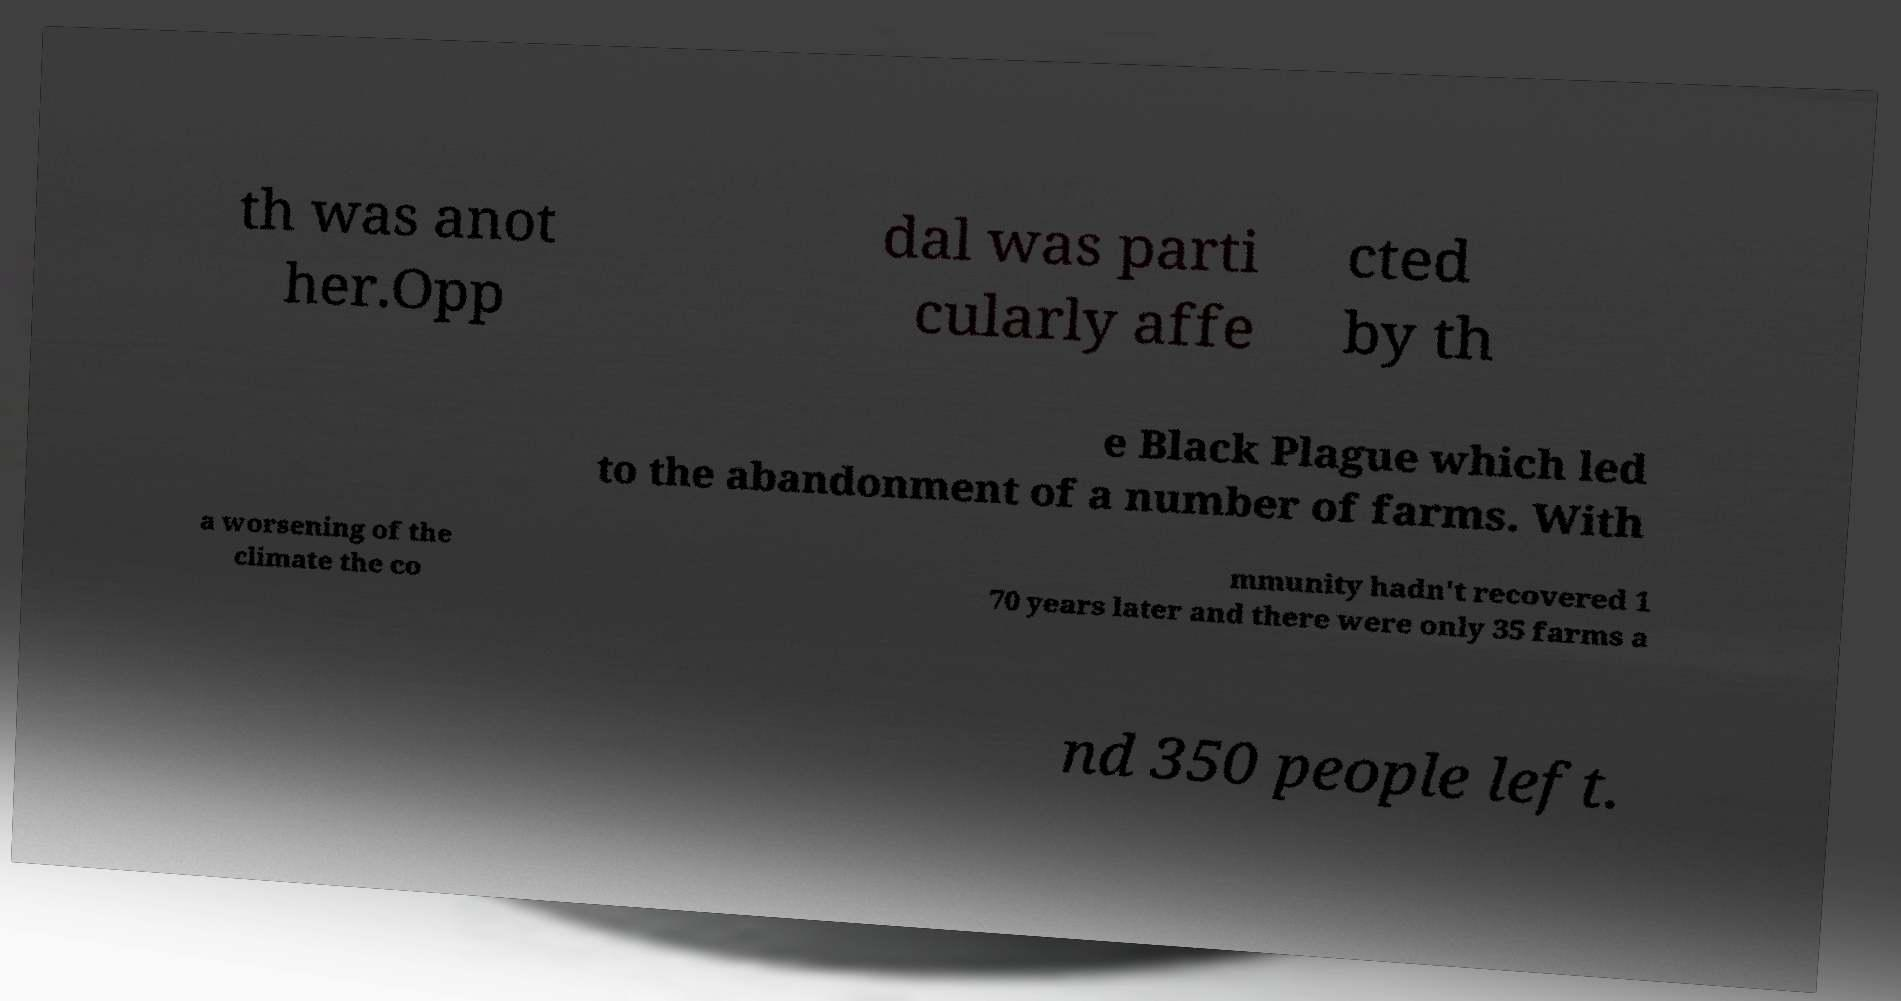Could you assist in decoding the text presented in this image and type it out clearly? th was anot her.Opp dal was parti cularly affe cted by th e Black Plague which led to the abandonment of a number of farms. With a worsening of the climate the co mmunity hadn't recovered 1 70 years later and there were only 35 farms a nd 350 people left. 